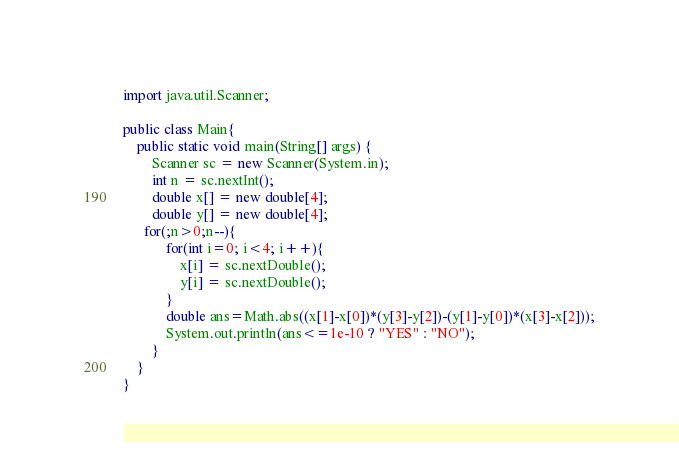Convert code to text. <code><loc_0><loc_0><loc_500><loc_500><_Java_>import java.util.Scanner;

public class Main{
    public static void main(String[] args) {
        Scanner sc = new Scanner(System.in);
        int n = sc.nextInt();
        double x[] = new double[4];
        double y[] = new double[4];
      for(;n>0;n--){
            for(int i=0; i<4; i++){
                x[i] = sc.nextDouble();
                y[i] = sc.nextDouble();
            }
            double ans=Math.abs((x[1]-x[0])*(y[3]-y[2])-(y[1]-y[0])*(x[3]-x[2]));
            System.out.println(ans<=1e-10 ? "YES" : "NO");
        }
    }
}</code> 